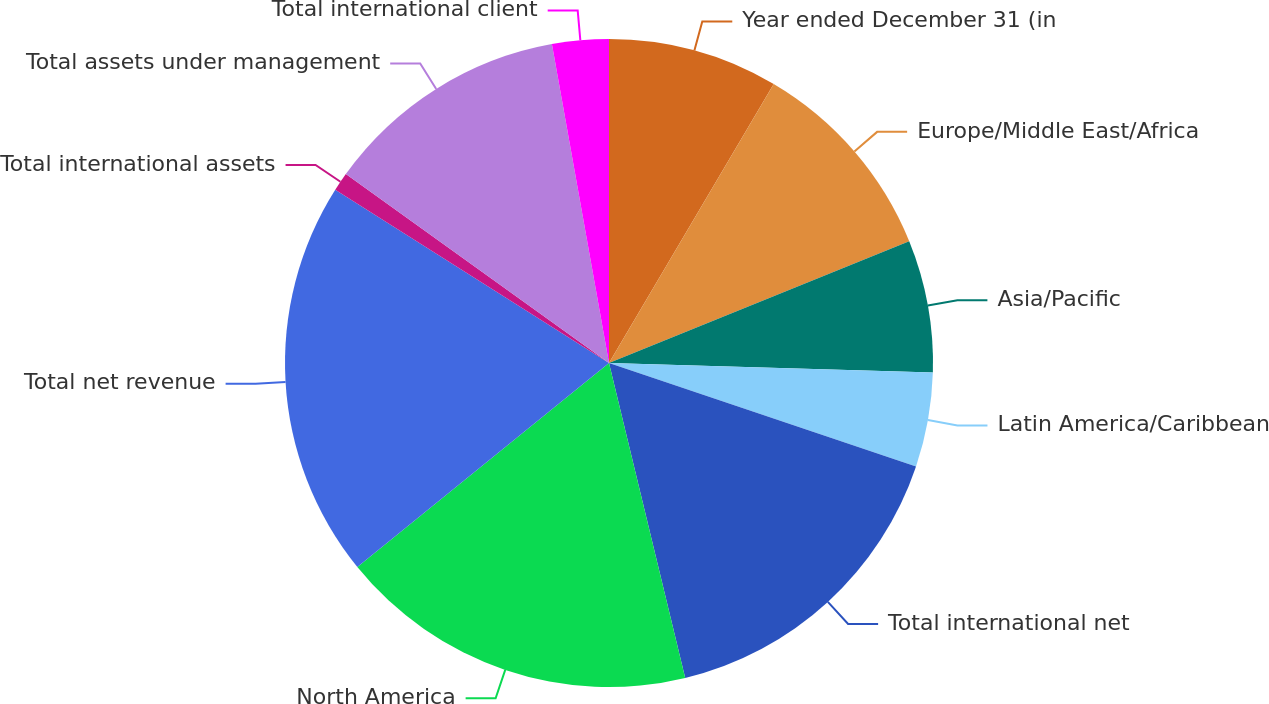<chart> <loc_0><loc_0><loc_500><loc_500><pie_chart><fcel>Year ended December 31 (in<fcel>Europe/Middle East/Africa<fcel>Asia/Pacific<fcel>Latin America/Caribbean<fcel>Total international net<fcel>North America<fcel>Total net revenue<fcel>Total international assets<fcel>Total assets under management<fcel>Total international client<nl><fcel>8.49%<fcel>10.38%<fcel>6.6%<fcel>4.71%<fcel>16.05%<fcel>17.94%<fcel>19.83%<fcel>0.93%<fcel>12.27%<fcel>2.82%<nl></chart> 